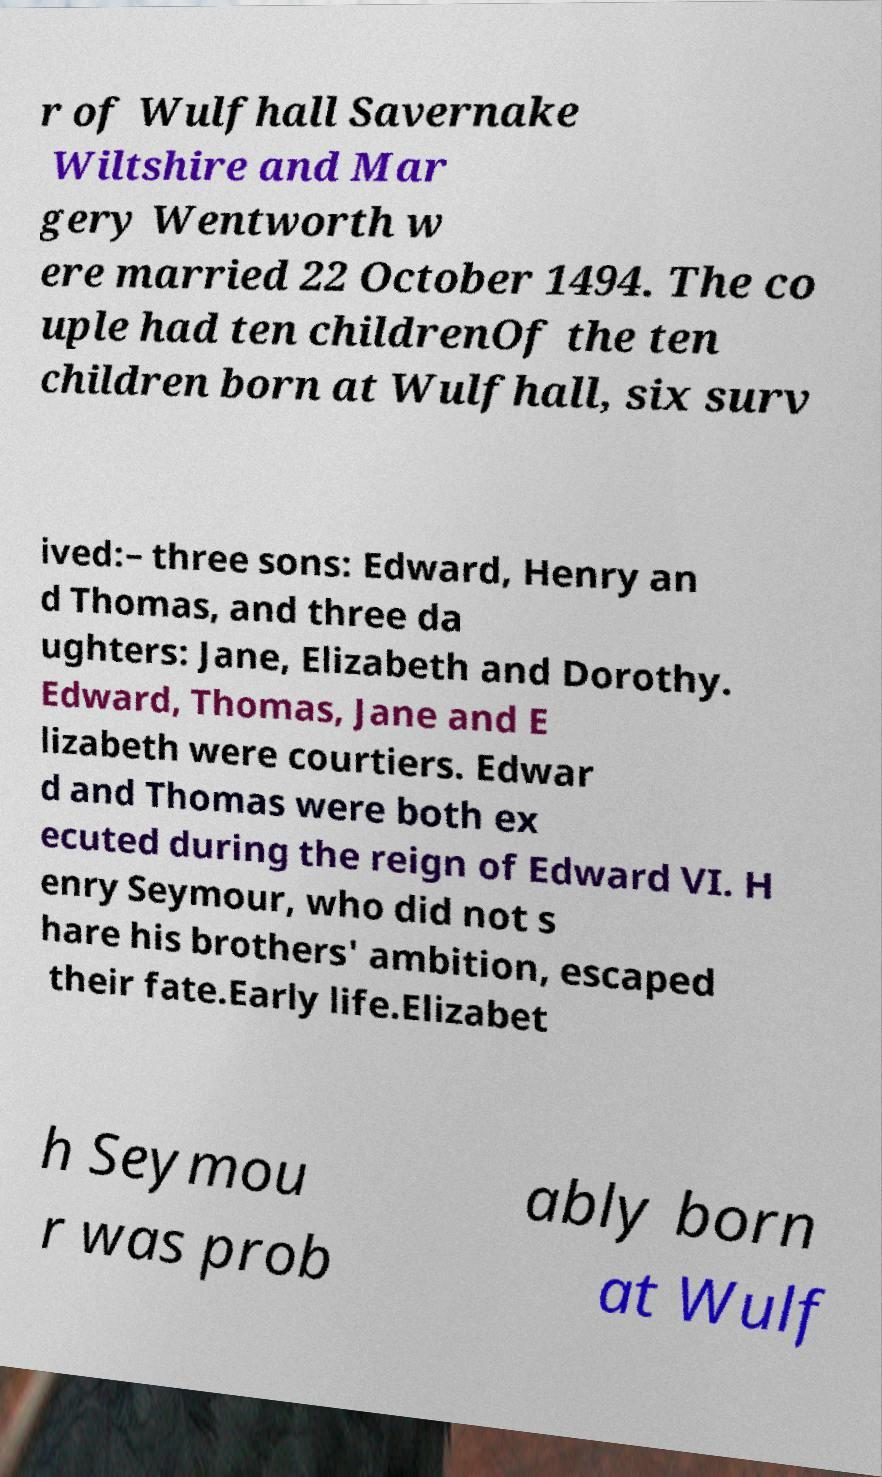Can you accurately transcribe the text from the provided image for me? r of Wulfhall Savernake Wiltshire and Mar gery Wentworth w ere married 22 October 1494. The co uple had ten childrenOf the ten children born at Wulfhall, six surv ived:– three sons: Edward, Henry an d Thomas, and three da ughters: Jane, Elizabeth and Dorothy. Edward, Thomas, Jane and E lizabeth were courtiers. Edwar d and Thomas were both ex ecuted during the reign of Edward VI. H enry Seymour, who did not s hare his brothers' ambition, escaped their fate.Early life.Elizabet h Seymou r was prob ably born at Wulf 